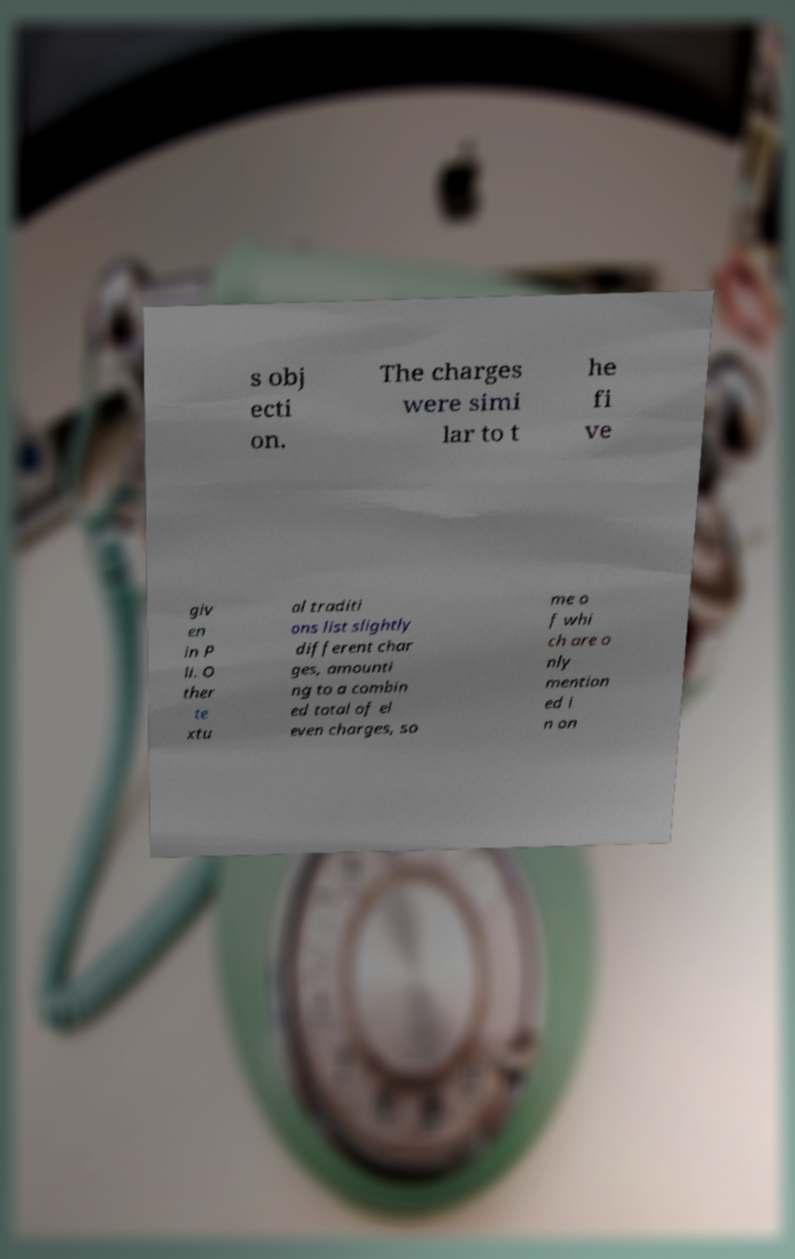What messages or text are displayed in this image? I need them in a readable, typed format. s obj ecti on. The charges were simi lar to t he fi ve giv en in P li. O ther te xtu al traditi ons list slightly different char ges, amounti ng to a combin ed total of el even charges, so me o f whi ch are o nly mention ed i n on 